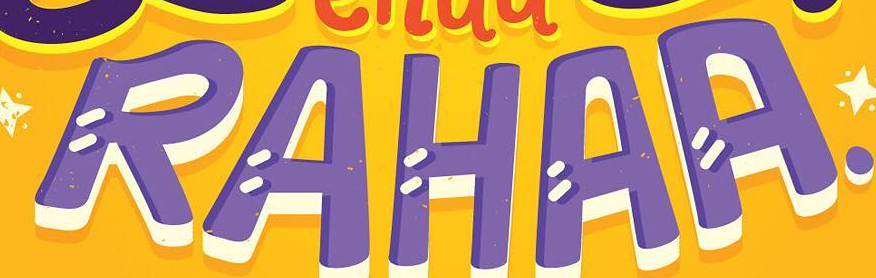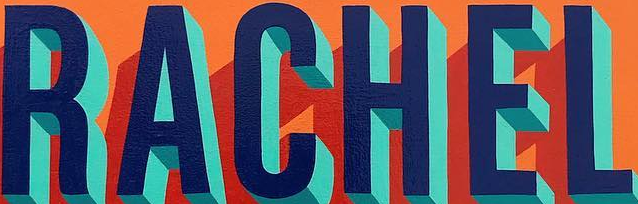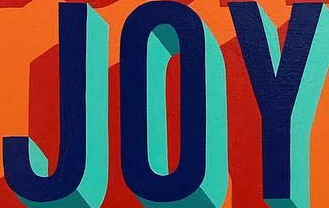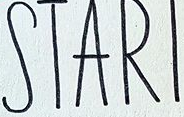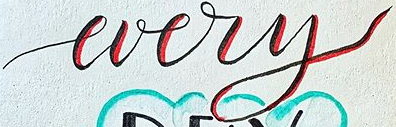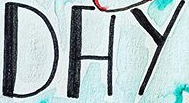What text is displayed in these images sequentially, separated by a semicolon? RAHAA; RACHEL; JOY; STARI; every; DAY 